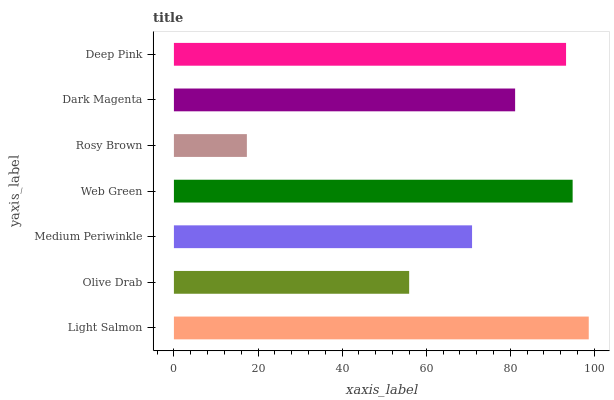Is Rosy Brown the minimum?
Answer yes or no. Yes. Is Light Salmon the maximum?
Answer yes or no. Yes. Is Olive Drab the minimum?
Answer yes or no. No. Is Olive Drab the maximum?
Answer yes or no. No. Is Light Salmon greater than Olive Drab?
Answer yes or no. Yes. Is Olive Drab less than Light Salmon?
Answer yes or no. Yes. Is Olive Drab greater than Light Salmon?
Answer yes or no. No. Is Light Salmon less than Olive Drab?
Answer yes or no. No. Is Dark Magenta the high median?
Answer yes or no. Yes. Is Dark Magenta the low median?
Answer yes or no. Yes. Is Rosy Brown the high median?
Answer yes or no. No. Is Medium Periwinkle the low median?
Answer yes or no. No. 